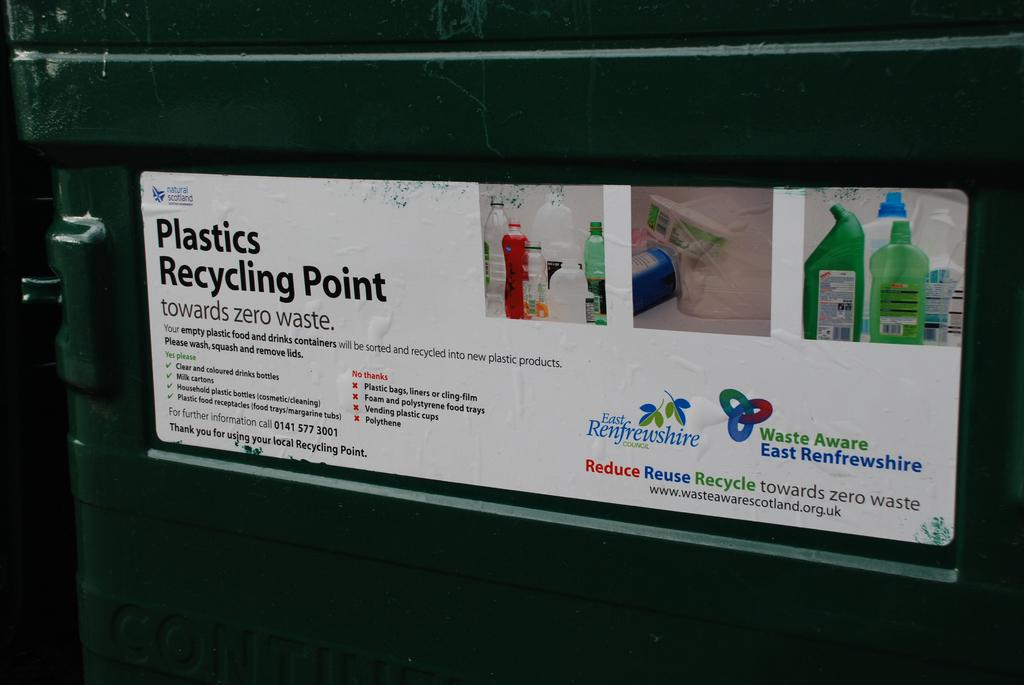<image>
Present a compact description of the photo's key features. a close up of an ad on a Plastics Recycling Point about Zero Waste 